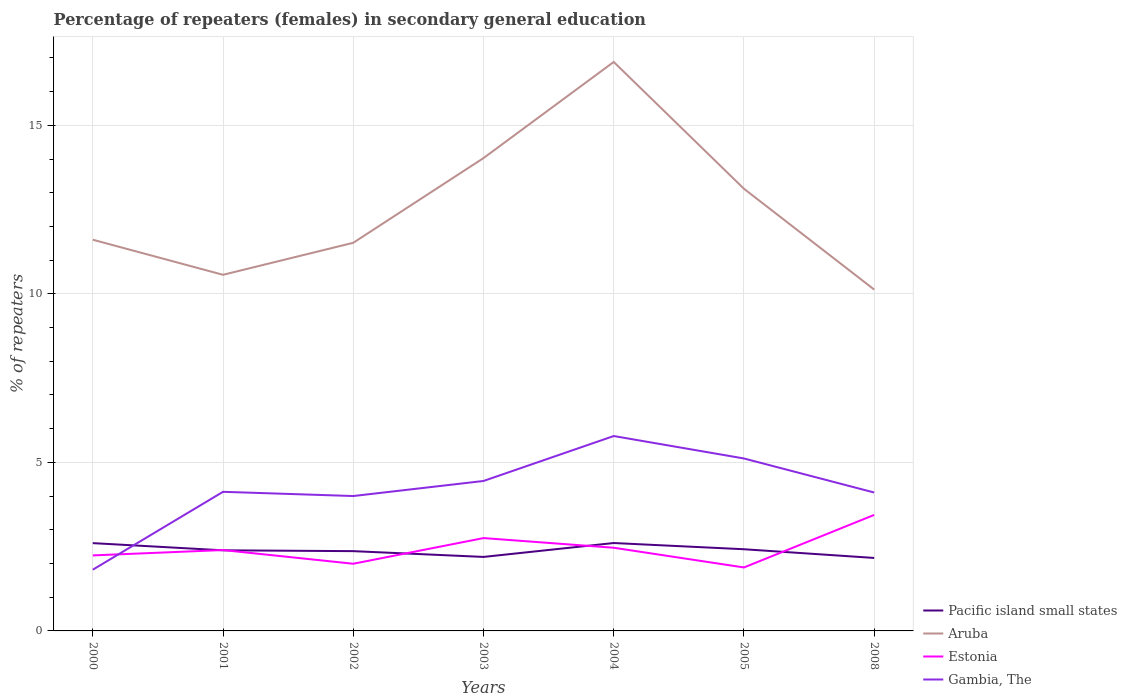How many different coloured lines are there?
Give a very brief answer. 4. Does the line corresponding to Aruba intersect with the line corresponding to Estonia?
Your response must be concise. No. Is the number of lines equal to the number of legend labels?
Give a very brief answer. Yes. Across all years, what is the maximum percentage of female repeaters in Gambia, The?
Keep it short and to the point. 1.82. What is the total percentage of female repeaters in Pacific island small states in the graph?
Keep it short and to the point. 0.18. What is the difference between the highest and the second highest percentage of female repeaters in Pacific island small states?
Offer a very short reply. 0.44. Is the percentage of female repeaters in Aruba strictly greater than the percentage of female repeaters in Estonia over the years?
Give a very brief answer. No. How many years are there in the graph?
Give a very brief answer. 7. Does the graph contain any zero values?
Your answer should be compact. No. Does the graph contain grids?
Your answer should be compact. Yes. Where does the legend appear in the graph?
Ensure brevity in your answer.  Bottom right. How many legend labels are there?
Your response must be concise. 4. How are the legend labels stacked?
Give a very brief answer. Vertical. What is the title of the graph?
Offer a terse response. Percentage of repeaters (females) in secondary general education. What is the label or title of the X-axis?
Provide a succinct answer. Years. What is the label or title of the Y-axis?
Offer a very short reply. % of repeaters. What is the % of repeaters of Pacific island small states in 2000?
Your answer should be compact. 2.6. What is the % of repeaters of Aruba in 2000?
Ensure brevity in your answer.  11.61. What is the % of repeaters in Estonia in 2000?
Provide a short and direct response. 2.24. What is the % of repeaters in Gambia, The in 2000?
Your answer should be compact. 1.82. What is the % of repeaters in Pacific island small states in 2001?
Ensure brevity in your answer.  2.39. What is the % of repeaters in Aruba in 2001?
Provide a short and direct response. 10.56. What is the % of repeaters of Estonia in 2001?
Keep it short and to the point. 2.4. What is the % of repeaters of Gambia, The in 2001?
Make the answer very short. 4.13. What is the % of repeaters in Pacific island small states in 2002?
Your answer should be compact. 2.37. What is the % of repeaters of Aruba in 2002?
Your answer should be very brief. 11.51. What is the % of repeaters in Estonia in 2002?
Offer a terse response. 1.99. What is the % of repeaters of Gambia, The in 2002?
Your response must be concise. 4. What is the % of repeaters of Pacific island small states in 2003?
Provide a succinct answer. 2.2. What is the % of repeaters in Aruba in 2003?
Your response must be concise. 14.03. What is the % of repeaters of Estonia in 2003?
Your answer should be very brief. 2.75. What is the % of repeaters of Gambia, The in 2003?
Provide a short and direct response. 4.45. What is the % of repeaters in Pacific island small states in 2004?
Your answer should be compact. 2.61. What is the % of repeaters in Aruba in 2004?
Keep it short and to the point. 16.88. What is the % of repeaters of Estonia in 2004?
Your answer should be very brief. 2.47. What is the % of repeaters in Gambia, The in 2004?
Give a very brief answer. 5.78. What is the % of repeaters of Pacific island small states in 2005?
Offer a very short reply. 2.42. What is the % of repeaters in Aruba in 2005?
Keep it short and to the point. 13.12. What is the % of repeaters in Estonia in 2005?
Your response must be concise. 1.88. What is the % of repeaters in Gambia, The in 2005?
Give a very brief answer. 5.12. What is the % of repeaters of Pacific island small states in 2008?
Your response must be concise. 2.16. What is the % of repeaters in Aruba in 2008?
Your answer should be compact. 10.13. What is the % of repeaters of Estonia in 2008?
Ensure brevity in your answer.  3.44. What is the % of repeaters in Gambia, The in 2008?
Offer a terse response. 4.11. Across all years, what is the maximum % of repeaters in Pacific island small states?
Ensure brevity in your answer.  2.61. Across all years, what is the maximum % of repeaters of Aruba?
Ensure brevity in your answer.  16.88. Across all years, what is the maximum % of repeaters in Estonia?
Keep it short and to the point. 3.44. Across all years, what is the maximum % of repeaters of Gambia, The?
Make the answer very short. 5.78. Across all years, what is the minimum % of repeaters of Pacific island small states?
Provide a succinct answer. 2.16. Across all years, what is the minimum % of repeaters in Aruba?
Give a very brief answer. 10.13. Across all years, what is the minimum % of repeaters of Estonia?
Provide a short and direct response. 1.88. Across all years, what is the minimum % of repeaters in Gambia, The?
Provide a succinct answer. 1.82. What is the total % of repeaters of Pacific island small states in the graph?
Your answer should be very brief. 16.75. What is the total % of repeaters of Aruba in the graph?
Your answer should be very brief. 87.83. What is the total % of repeaters of Estonia in the graph?
Ensure brevity in your answer.  17.18. What is the total % of repeaters of Gambia, The in the graph?
Keep it short and to the point. 29.4. What is the difference between the % of repeaters in Pacific island small states in 2000 and that in 2001?
Your answer should be compact. 0.21. What is the difference between the % of repeaters of Aruba in 2000 and that in 2001?
Make the answer very short. 1.04. What is the difference between the % of repeaters of Estonia in 2000 and that in 2001?
Make the answer very short. -0.16. What is the difference between the % of repeaters of Gambia, The in 2000 and that in 2001?
Make the answer very short. -2.31. What is the difference between the % of repeaters of Pacific island small states in 2000 and that in 2002?
Your answer should be very brief. 0.24. What is the difference between the % of repeaters in Aruba in 2000 and that in 2002?
Keep it short and to the point. 0.09. What is the difference between the % of repeaters in Estonia in 2000 and that in 2002?
Provide a succinct answer. 0.25. What is the difference between the % of repeaters of Gambia, The in 2000 and that in 2002?
Provide a succinct answer. -2.19. What is the difference between the % of repeaters of Pacific island small states in 2000 and that in 2003?
Provide a succinct answer. 0.41. What is the difference between the % of repeaters of Aruba in 2000 and that in 2003?
Offer a terse response. -2.42. What is the difference between the % of repeaters in Estonia in 2000 and that in 2003?
Your answer should be compact. -0.51. What is the difference between the % of repeaters of Gambia, The in 2000 and that in 2003?
Offer a terse response. -2.63. What is the difference between the % of repeaters in Pacific island small states in 2000 and that in 2004?
Provide a short and direct response. -0. What is the difference between the % of repeaters of Aruba in 2000 and that in 2004?
Your answer should be very brief. -5.27. What is the difference between the % of repeaters in Estonia in 2000 and that in 2004?
Provide a short and direct response. -0.23. What is the difference between the % of repeaters of Gambia, The in 2000 and that in 2004?
Keep it short and to the point. -3.97. What is the difference between the % of repeaters of Pacific island small states in 2000 and that in 2005?
Give a very brief answer. 0.18. What is the difference between the % of repeaters of Aruba in 2000 and that in 2005?
Your response must be concise. -1.51. What is the difference between the % of repeaters of Estonia in 2000 and that in 2005?
Keep it short and to the point. 0.36. What is the difference between the % of repeaters of Gambia, The in 2000 and that in 2005?
Offer a very short reply. -3.3. What is the difference between the % of repeaters of Pacific island small states in 2000 and that in 2008?
Your answer should be compact. 0.44. What is the difference between the % of repeaters in Aruba in 2000 and that in 2008?
Keep it short and to the point. 1.48. What is the difference between the % of repeaters of Estonia in 2000 and that in 2008?
Offer a terse response. -1.2. What is the difference between the % of repeaters of Gambia, The in 2000 and that in 2008?
Your response must be concise. -2.29. What is the difference between the % of repeaters in Pacific island small states in 2001 and that in 2002?
Your answer should be very brief. 0.02. What is the difference between the % of repeaters of Aruba in 2001 and that in 2002?
Give a very brief answer. -0.95. What is the difference between the % of repeaters of Estonia in 2001 and that in 2002?
Offer a terse response. 0.41. What is the difference between the % of repeaters in Gambia, The in 2001 and that in 2002?
Provide a succinct answer. 0.13. What is the difference between the % of repeaters in Pacific island small states in 2001 and that in 2003?
Your response must be concise. 0.2. What is the difference between the % of repeaters in Aruba in 2001 and that in 2003?
Your answer should be compact. -3.46. What is the difference between the % of repeaters in Estonia in 2001 and that in 2003?
Your answer should be compact. -0.35. What is the difference between the % of repeaters in Gambia, The in 2001 and that in 2003?
Provide a succinct answer. -0.32. What is the difference between the % of repeaters of Pacific island small states in 2001 and that in 2004?
Provide a short and direct response. -0.22. What is the difference between the % of repeaters of Aruba in 2001 and that in 2004?
Provide a short and direct response. -6.31. What is the difference between the % of repeaters in Estonia in 2001 and that in 2004?
Give a very brief answer. -0.07. What is the difference between the % of repeaters in Gambia, The in 2001 and that in 2004?
Your answer should be compact. -1.65. What is the difference between the % of repeaters of Pacific island small states in 2001 and that in 2005?
Your answer should be compact. -0.03. What is the difference between the % of repeaters in Aruba in 2001 and that in 2005?
Provide a succinct answer. -2.55. What is the difference between the % of repeaters in Estonia in 2001 and that in 2005?
Provide a short and direct response. 0.52. What is the difference between the % of repeaters in Gambia, The in 2001 and that in 2005?
Your response must be concise. -0.99. What is the difference between the % of repeaters of Pacific island small states in 2001 and that in 2008?
Offer a very short reply. 0.23. What is the difference between the % of repeaters in Aruba in 2001 and that in 2008?
Your answer should be compact. 0.44. What is the difference between the % of repeaters of Estonia in 2001 and that in 2008?
Your answer should be compact. -1.04. What is the difference between the % of repeaters in Gambia, The in 2001 and that in 2008?
Give a very brief answer. 0.02. What is the difference between the % of repeaters of Pacific island small states in 2002 and that in 2003?
Offer a very short reply. 0.17. What is the difference between the % of repeaters of Aruba in 2002 and that in 2003?
Make the answer very short. -2.51. What is the difference between the % of repeaters of Estonia in 2002 and that in 2003?
Your answer should be compact. -0.76. What is the difference between the % of repeaters in Gambia, The in 2002 and that in 2003?
Give a very brief answer. -0.45. What is the difference between the % of repeaters of Pacific island small states in 2002 and that in 2004?
Provide a succinct answer. -0.24. What is the difference between the % of repeaters in Aruba in 2002 and that in 2004?
Your answer should be very brief. -5.36. What is the difference between the % of repeaters in Estonia in 2002 and that in 2004?
Make the answer very short. -0.47. What is the difference between the % of repeaters of Gambia, The in 2002 and that in 2004?
Provide a short and direct response. -1.78. What is the difference between the % of repeaters in Pacific island small states in 2002 and that in 2005?
Provide a succinct answer. -0.06. What is the difference between the % of repeaters in Aruba in 2002 and that in 2005?
Your answer should be very brief. -1.6. What is the difference between the % of repeaters in Estonia in 2002 and that in 2005?
Keep it short and to the point. 0.11. What is the difference between the % of repeaters of Gambia, The in 2002 and that in 2005?
Your response must be concise. -1.11. What is the difference between the % of repeaters of Pacific island small states in 2002 and that in 2008?
Your response must be concise. 0.2. What is the difference between the % of repeaters of Aruba in 2002 and that in 2008?
Give a very brief answer. 1.39. What is the difference between the % of repeaters in Estonia in 2002 and that in 2008?
Your answer should be compact. -1.45. What is the difference between the % of repeaters in Gambia, The in 2002 and that in 2008?
Give a very brief answer. -0.1. What is the difference between the % of repeaters of Pacific island small states in 2003 and that in 2004?
Offer a very short reply. -0.41. What is the difference between the % of repeaters in Aruba in 2003 and that in 2004?
Ensure brevity in your answer.  -2.85. What is the difference between the % of repeaters of Estonia in 2003 and that in 2004?
Provide a succinct answer. 0.29. What is the difference between the % of repeaters of Gambia, The in 2003 and that in 2004?
Make the answer very short. -1.33. What is the difference between the % of repeaters in Pacific island small states in 2003 and that in 2005?
Your answer should be compact. -0.23. What is the difference between the % of repeaters of Aruba in 2003 and that in 2005?
Provide a succinct answer. 0.91. What is the difference between the % of repeaters in Estonia in 2003 and that in 2005?
Offer a very short reply. 0.87. What is the difference between the % of repeaters in Gambia, The in 2003 and that in 2005?
Your response must be concise. -0.67. What is the difference between the % of repeaters of Pacific island small states in 2003 and that in 2008?
Offer a terse response. 0.03. What is the difference between the % of repeaters of Aruba in 2003 and that in 2008?
Provide a short and direct response. 3.9. What is the difference between the % of repeaters in Estonia in 2003 and that in 2008?
Provide a short and direct response. -0.69. What is the difference between the % of repeaters of Gambia, The in 2003 and that in 2008?
Your answer should be compact. 0.34. What is the difference between the % of repeaters of Pacific island small states in 2004 and that in 2005?
Make the answer very short. 0.18. What is the difference between the % of repeaters in Aruba in 2004 and that in 2005?
Your answer should be compact. 3.76. What is the difference between the % of repeaters in Estonia in 2004 and that in 2005?
Offer a very short reply. 0.58. What is the difference between the % of repeaters of Gambia, The in 2004 and that in 2005?
Keep it short and to the point. 0.67. What is the difference between the % of repeaters of Pacific island small states in 2004 and that in 2008?
Offer a terse response. 0.44. What is the difference between the % of repeaters in Aruba in 2004 and that in 2008?
Offer a terse response. 6.75. What is the difference between the % of repeaters in Estonia in 2004 and that in 2008?
Ensure brevity in your answer.  -0.97. What is the difference between the % of repeaters of Gambia, The in 2004 and that in 2008?
Give a very brief answer. 1.68. What is the difference between the % of repeaters of Pacific island small states in 2005 and that in 2008?
Your answer should be very brief. 0.26. What is the difference between the % of repeaters of Aruba in 2005 and that in 2008?
Give a very brief answer. 2.99. What is the difference between the % of repeaters of Estonia in 2005 and that in 2008?
Provide a short and direct response. -1.56. What is the difference between the % of repeaters in Gambia, The in 2005 and that in 2008?
Your response must be concise. 1.01. What is the difference between the % of repeaters of Pacific island small states in 2000 and the % of repeaters of Aruba in 2001?
Keep it short and to the point. -7.96. What is the difference between the % of repeaters of Pacific island small states in 2000 and the % of repeaters of Estonia in 2001?
Your answer should be very brief. 0.21. What is the difference between the % of repeaters of Pacific island small states in 2000 and the % of repeaters of Gambia, The in 2001?
Provide a short and direct response. -1.52. What is the difference between the % of repeaters in Aruba in 2000 and the % of repeaters in Estonia in 2001?
Offer a terse response. 9.21. What is the difference between the % of repeaters of Aruba in 2000 and the % of repeaters of Gambia, The in 2001?
Ensure brevity in your answer.  7.48. What is the difference between the % of repeaters of Estonia in 2000 and the % of repeaters of Gambia, The in 2001?
Give a very brief answer. -1.89. What is the difference between the % of repeaters of Pacific island small states in 2000 and the % of repeaters of Aruba in 2002?
Make the answer very short. -8.91. What is the difference between the % of repeaters of Pacific island small states in 2000 and the % of repeaters of Estonia in 2002?
Make the answer very short. 0.61. What is the difference between the % of repeaters in Pacific island small states in 2000 and the % of repeaters in Gambia, The in 2002?
Keep it short and to the point. -1.4. What is the difference between the % of repeaters in Aruba in 2000 and the % of repeaters in Estonia in 2002?
Offer a terse response. 9.61. What is the difference between the % of repeaters of Aruba in 2000 and the % of repeaters of Gambia, The in 2002?
Keep it short and to the point. 7.6. What is the difference between the % of repeaters of Estonia in 2000 and the % of repeaters of Gambia, The in 2002?
Ensure brevity in your answer.  -1.76. What is the difference between the % of repeaters in Pacific island small states in 2000 and the % of repeaters in Aruba in 2003?
Offer a very short reply. -11.42. What is the difference between the % of repeaters of Pacific island small states in 2000 and the % of repeaters of Estonia in 2003?
Provide a short and direct response. -0.15. What is the difference between the % of repeaters of Pacific island small states in 2000 and the % of repeaters of Gambia, The in 2003?
Make the answer very short. -1.84. What is the difference between the % of repeaters of Aruba in 2000 and the % of repeaters of Estonia in 2003?
Keep it short and to the point. 8.85. What is the difference between the % of repeaters in Aruba in 2000 and the % of repeaters in Gambia, The in 2003?
Your response must be concise. 7.16. What is the difference between the % of repeaters in Estonia in 2000 and the % of repeaters in Gambia, The in 2003?
Ensure brevity in your answer.  -2.21. What is the difference between the % of repeaters in Pacific island small states in 2000 and the % of repeaters in Aruba in 2004?
Your answer should be very brief. -14.27. What is the difference between the % of repeaters of Pacific island small states in 2000 and the % of repeaters of Estonia in 2004?
Your answer should be compact. 0.14. What is the difference between the % of repeaters in Pacific island small states in 2000 and the % of repeaters in Gambia, The in 2004?
Your answer should be very brief. -3.18. What is the difference between the % of repeaters in Aruba in 2000 and the % of repeaters in Estonia in 2004?
Keep it short and to the point. 9.14. What is the difference between the % of repeaters of Aruba in 2000 and the % of repeaters of Gambia, The in 2004?
Make the answer very short. 5.82. What is the difference between the % of repeaters in Estonia in 2000 and the % of repeaters in Gambia, The in 2004?
Give a very brief answer. -3.54. What is the difference between the % of repeaters in Pacific island small states in 2000 and the % of repeaters in Aruba in 2005?
Make the answer very short. -10.51. What is the difference between the % of repeaters of Pacific island small states in 2000 and the % of repeaters of Estonia in 2005?
Provide a short and direct response. 0.72. What is the difference between the % of repeaters in Pacific island small states in 2000 and the % of repeaters in Gambia, The in 2005?
Give a very brief answer. -2.51. What is the difference between the % of repeaters of Aruba in 2000 and the % of repeaters of Estonia in 2005?
Offer a very short reply. 9.72. What is the difference between the % of repeaters in Aruba in 2000 and the % of repeaters in Gambia, The in 2005?
Your response must be concise. 6.49. What is the difference between the % of repeaters in Estonia in 2000 and the % of repeaters in Gambia, The in 2005?
Provide a short and direct response. -2.88. What is the difference between the % of repeaters of Pacific island small states in 2000 and the % of repeaters of Aruba in 2008?
Make the answer very short. -7.52. What is the difference between the % of repeaters of Pacific island small states in 2000 and the % of repeaters of Estonia in 2008?
Ensure brevity in your answer.  -0.84. What is the difference between the % of repeaters in Pacific island small states in 2000 and the % of repeaters in Gambia, The in 2008?
Provide a short and direct response. -1.5. What is the difference between the % of repeaters in Aruba in 2000 and the % of repeaters in Estonia in 2008?
Give a very brief answer. 8.16. What is the difference between the % of repeaters in Aruba in 2000 and the % of repeaters in Gambia, The in 2008?
Your response must be concise. 7.5. What is the difference between the % of repeaters of Estonia in 2000 and the % of repeaters of Gambia, The in 2008?
Ensure brevity in your answer.  -1.87. What is the difference between the % of repeaters of Pacific island small states in 2001 and the % of repeaters of Aruba in 2002?
Offer a terse response. -9.12. What is the difference between the % of repeaters of Pacific island small states in 2001 and the % of repeaters of Estonia in 2002?
Provide a succinct answer. 0.4. What is the difference between the % of repeaters of Pacific island small states in 2001 and the % of repeaters of Gambia, The in 2002?
Ensure brevity in your answer.  -1.61. What is the difference between the % of repeaters in Aruba in 2001 and the % of repeaters in Estonia in 2002?
Keep it short and to the point. 8.57. What is the difference between the % of repeaters of Aruba in 2001 and the % of repeaters of Gambia, The in 2002?
Provide a succinct answer. 6.56. What is the difference between the % of repeaters of Estonia in 2001 and the % of repeaters of Gambia, The in 2002?
Provide a short and direct response. -1.6. What is the difference between the % of repeaters in Pacific island small states in 2001 and the % of repeaters in Aruba in 2003?
Keep it short and to the point. -11.64. What is the difference between the % of repeaters of Pacific island small states in 2001 and the % of repeaters of Estonia in 2003?
Keep it short and to the point. -0.36. What is the difference between the % of repeaters in Pacific island small states in 2001 and the % of repeaters in Gambia, The in 2003?
Provide a short and direct response. -2.06. What is the difference between the % of repeaters of Aruba in 2001 and the % of repeaters of Estonia in 2003?
Offer a very short reply. 7.81. What is the difference between the % of repeaters in Aruba in 2001 and the % of repeaters in Gambia, The in 2003?
Make the answer very short. 6.12. What is the difference between the % of repeaters in Estonia in 2001 and the % of repeaters in Gambia, The in 2003?
Provide a succinct answer. -2.05. What is the difference between the % of repeaters in Pacific island small states in 2001 and the % of repeaters in Aruba in 2004?
Provide a short and direct response. -14.49. What is the difference between the % of repeaters of Pacific island small states in 2001 and the % of repeaters of Estonia in 2004?
Your response must be concise. -0.08. What is the difference between the % of repeaters of Pacific island small states in 2001 and the % of repeaters of Gambia, The in 2004?
Your response must be concise. -3.39. What is the difference between the % of repeaters of Aruba in 2001 and the % of repeaters of Estonia in 2004?
Give a very brief answer. 8.1. What is the difference between the % of repeaters in Aruba in 2001 and the % of repeaters in Gambia, The in 2004?
Offer a terse response. 4.78. What is the difference between the % of repeaters of Estonia in 2001 and the % of repeaters of Gambia, The in 2004?
Give a very brief answer. -3.38. What is the difference between the % of repeaters of Pacific island small states in 2001 and the % of repeaters of Aruba in 2005?
Make the answer very short. -10.73. What is the difference between the % of repeaters in Pacific island small states in 2001 and the % of repeaters in Estonia in 2005?
Your answer should be compact. 0.51. What is the difference between the % of repeaters in Pacific island small states in 2001 and the % of repeaters in Gambia, The in 2005?
Offer a very short reply. -2.72. What is the difference between the % of repeaters in Aruba in 2001 and the % of repeaters in Estonia in 2005?
Provide a succinct answer. 8.68. What is the difference between the % of repeaters in Aruba in 2001 and the % of repeaters in Gambia, The in 2005?
Provide a short and direct response. 5.45. What is the difference between the % of repeaters of Estonia in 2001 and the % of repeaters of Gambia, The in 2005?
Give a very brief answer. -2.72. What is the difference between the % of repeaters of Pacific island small states in 2001 and the % of repeaters of Aruba in 2008?
Your answer should be compact. -7.74. What is the difference between the % of repeaters of Pacific island small states in 2001 and the % of repeaters of Estonia in 2008?
Your response must be concise. -1.05. What is the difference between the % of repeaters in Pacific island small states in 2001 and the % of repeaters in Gambia, The in 2008?
Provide a succinct answer. -1.71. What is the difference between the % of repeaters of Aruba in 2001 and the % of repeaters of Estonia in 2008?
Provide a short and direct response. 7.12. What is the difference between the % of repeaters of Aruba in 2001 and the % of repeaters of Gambia, The in 2008?
Your answer should be compact. 6.46. What is the difference between the % of repeaters in Estonia in 2001 and the % of repeaters in Gambia, The in 2008?
Offer a terse response. -1.71. What is the difference between the % of repeaters of Pacific island small states in 2002 and the % of repeaters of Aruba in 2003?
Your answer should be very brief. -11.66. What is the difference between the % of repeaters in Pacific island small states in 2002 and the % of repeaters in Estonia in 2003?
Give a very brief answer. -0.39. What is the difference between the % of repeaters in Pacific island small states in 2002 and the % of repeaters in Gambia, The in 2003?
Give a very brief answer. -2.08. What is the difference between the % of repeaters of Aruba in 2002 and the % of repeaters of Estonia in 2003?
Give a very brief answer. 8.76. What is the difference between the % of repeaters of Aruba in 2002 and the % of repeaters of Gambia, The in 2003?
Your response must be concise. 7.07. What is the difference between the % of repeaters in Estonia in 2002 and the % of repeaters in Gambia, The in 2003?
Ensure brevity in your answer.  -2.46. What is the difference between the % of repeaters in Pacific island small states in 2002 and the % of repeaters in Aruba in 2004?
Your answer should be very brief. -14.51. What is the difference between the % of repeaters of Pacific island small states in 2002 and the % of repeaters of Estonia in 2004?
Ensure brevity in your answer.  -0.1. What is the difference between the % of repeaters in Pacific island small states in 2002 and the % of repeaters in Gambia, The in 2004?
Offer a very short reply. -3.41. What is the difference between the % of repeaters in Aruba in 2002 and the % of repeaters in Estonia in 2004?
Keep it short and to the point. 9.05. What is the difference between the % of repeaters in Aruba in 2002 and the % of repeaters in Gambia, The in 2004?
Your response must be concise. 5.73. What is the difference between the % of repeaters of Estonia in 2002 and the % of repeaters of Gambia, The in 2004?
Offer a very short reply. -3.79. What is the difference between the % of repeaters of Pacific island small states in 2002 and the % of repeaters of Aruba in 2005?
Provide a succinct answer. -10.75. What is the difference between the % of repeaters of Pacific island small states in 2002 and the % of repeaters of Estonia in 2005?
Provide a succinct answer. 0.48. What is the difference between the % of repeaters in Pacific island small states in 2002 and the % of repeaters in Gambia, The in 2005?
Offer a very short reply. -2.75. What is the difference between the % of repeaters of Aruba in 2002 and the % of repeaters of Estonia in 2005?
Provide a succinct answer. 9.63. What is the difference between the % of repeaters in Aruba in 2002 and the % of repeaters in Gambia, The in 2005?
Your answer should be very brief. 6.4. What is the difference between the % of repeaters in Estonia in 2002 and the % of repeaters in Gambia, The in 2005?
Make the answer very short. -3.12. What is the difference between the % of repeaters of Pacific island small states in 2002 and the % of repeaters of Aruba in 2008?
Offer a very short reply. -7.76. What is the difference between the % of repeaters in Pacific island small states in 2002 and the % of repeaters in Estonia in 2008?
Your answer should be very brief. -1.07. What is the difference between the % of repeaters in Pacific island small states in 2002 and the % of repeaters in Gambia, The in 2008?
Your answer should be very brief. -1.74. What is the difference between the % of repeaters of Aruba in 2002 and the % of repeaters of Estonia in 2008?
Offer a terse response. 8.07. What is the difference between the % of repeaters of Aruba in 2002 and the % of repeaters of Gambia, The in 2008?
Offer a very short reply. 7.41. What is the difference between the % of repeaters in Estonia in 2002 and the % of repeaters in Gambia, The in 2008?
Provide a succinct answer. -2.11. What is the difference between the % of repeaters in Pacific island small states in 2003 and the % of repeaters in Aruba in 2004?
Provide a succinct answer. -14.68. What is the difference between the % of repeaters in Pacific island small states in 2003 and the % of repeaters in Estonia in 2004?
Offer a terse response. -0.27. What is the difference between the % of repeaters of Pacific island small states in 2003 and the % of repeaters of Gambia, The in 2004?
Offer a terse response. -3.59. What is the difference between the % of repeaters in Aruba in 2003 and the % of repeaters in Estonia in 2004?
Provide a short and direct response. 11.56. What is the difference between the % of repeaters of Aruba in 2003 and the % of repeaters of Gambia, The in 2004?
Ensure brevity in your answer.  8.25. What is the difference between the % of repeaters in Estonia in 2003 and the % of repeaters in Gambia, The in 2004?
Provide a succinct answer. -3.03. What is the difference between the % of repeaters in Pacific island small states in 2003 and the % of repeaters in Aruba in 2005?
Keep it short and to the point. -10.92. What is the difference between the % of repeaters of Pacific island small states in 2003 and the % of repeaters of Estonia in 2005?
Keep it short and to the point. 0.31. What is the difference between the % of repeaters in Pacific island small states in 2003 and the % of repeaters in Gambia, The in 2005?
Offer a very short reply. -2.92. What is the difference between the % of repeaters in Aruba in 2003 and the % of repeaters in Estonia in 2005?
Make the answer very short. 12.14. What is the difference between the % of repeaters of Aruba in 2003 and the % of repeaters of Gambia, The in 2005?
Make the answer very short. 8.91. What is the difference between the % of repeaters of Estonia in 2003 and the % of repeaters of Gambia, The in 2005?
Make the answer very short. -2.36. What is the difference between the % of repeaters in Pacific island small states in 2003 and the % of repeaters in Aruba in 2008?
Keep it short and to the point. -7.93. What is the difference between the % of repeaters in Pacific island small states in 2003 and the % of repeaters in Estonia in 2008?
Offer a terse response. -1.25. What is the difference between the % of repeaters in Pacific island small states in 2003 and the % of repeaters in Gambia, The in 2008?
Give a very brief answer. -1.91. What is the difference between the % of repeaters of Aruba in 2003 and the % of repeaters of Estonia in 2008?
Offer a very short reply. 10.59. What is the difference between the % of repeaters in Aruba in 2003 and the % of repeaters in Gambia, The in 2008?
Keep it short and to the point. 9.92. What is the difference between the % of repeaters of Estonia in 2003 and the % of repeaters of Gambia, The in 2008?
Ensure brevity in your answer.  -1.35. What is the difference between the % of repeaters in Pacific island small states in 2004 and the % of repeaters in Aruba in 2005?
Make the answer very short. -10.51. What is the difference between the % of repeaters in Pacific island small states in 2004 and the % of repeaters in Estonia in 2005?
Your response must be concise. 0.72. What is the difference between the % of repeaters in Pacific island small states in 2004 and the % of repeaters in Gambia, The in 2005?
Make the answer very short. -2.51. What is the difference between the % of repeaters of Aruba in 2004 and the % of repeaters of Estonia in 2005?
Keep it short and to the point. 15. What is the difference between the % of repeaters in Aruba in 2004 and the % of repeaters in Gambia, The in 2005?
Keep it short and to the point. 11.76. What is the difference between the % of repeaters of Estonia in 2004 and the % of repeaters of Gambia, The in 2005?
Give a very brief answer. -2.65. What is the difference between the % of repeaters in Pacific island small states in 2004 and the % of repeaters in Aruba in 2008?
Your answer should be very brief. -7.52. What is the difference between the % of repeaters of Pacific island small states in 2004 and the % of repeaters of Estonia in 2008?
Offer a terse response. -0.83. What is the difference between the % of repeaters in Pacific island small states in 2004 and the % of repeaters in Gambia, The in 2008?
Give a very brief answer. -1.5. What is the difference between the % of repeaters of Aruba in 2004 and the % of repeaters of Estonia in 2008?
Offer a terse response. 13.44. What is the difference between the % of repeaters in Aruba in 2004 and the % of repeaters in Gambia, The in 2008?
Offer a terse response. 12.77. What is the difference between the % of repeaters in Estonia in 2004 and the % of repeaters in Gambia, The in 2008?
Keep it short and to the point. -1.64. What is the difference between the % of repeaters of Pacific island small states in 2005 and the % of repeaters of Aruba in 2008?
Offer a terse response. -7.7. What is the difference between the % of repeaters of Pacific island small states in 2005 and the % of repeaters of Estonia in 2008?
Provide a short and direct response. -1.02. What is the difference between the % of repeaters in Pacific island small states in 2005 and the % of repeaters in Gambia, The in 2008?
Offer a terse response. -1.68. What is the difference between the % of repeaters of Aruba in 2005 and the % of repeaters of Estonia in 2008?
Ensure brevity in your answer.  9.68. What is the difference between the % of repeaters of Aruba in 2005 and the % of repeaters of Gambia, The in 2008?
Your answer should be very brief. 9.01. What is the difference between the % of repeaters in Estonia in 2005 and the % of repeaters in Gambia, The in 2008?
Offer a very short reply. -2.22. What is the average % of repeaters of Pacific island small states per year?
Provide a short and direct response. 2.39. What is the average % of repeaters in Aruba per year?
Make the answer very short. 12.55. What is the average % of repeaters of Estonia per year?
Give a very brief answer. 2.45. What is the average % of repeaters of Gambia, The per year?
Your answer should be very brief. 4.2. In the year 2000, what is the difference between the % of repeaters in Pacific island small states and % of repeaters in Aruba?
Give a very brief answer. -9. In the year 2000, what is the difference between the % of repeaters in Pacific island small states and % of repeaters in Estonia?
Offer a terse response. 0.36. In the year 2000, what is the difference between the % of repeaters in Pacific island small states and % of repeaters in Gambia, The?
Offer a terse response. 0.79. In the year 2000, what is the difference between the % of repeaters in Aruba and % of repeaters in Estonia?
Ensure brevity in your answer.  9.37. In the year 2000, what is the difference between the % of repeaters of Aruba and % of repeaters of Gambia, The?
Offer a terse response. 9.79. In the year 2000, what is the difference between the % of repeaters in Estonia and % of repeaters in Gambia, The?
Provide a short and direct response. 0.42. In the year 2001, what is the difference between the % of repeaters in Pacific island small states and % of repeaters in Aruba?
Make the answer very short. -8.17. In the year 2001, what is the difference between the % of repeaters of Pacific island small states and % of repeaters of Estonia?
Your answer should be compact. -0.01. In the year 2001, what is the difference between the % of repeaters in Pacific island small states and % of repeaters in Gambia, The?
Give a very brief answer. -1.74. In the year 2001, what is the difference between the % of repeaters of Aruba and % of repeaters of Estonia?
Provide a succinct answer. 8.17. In the year 2001, what is the difference between the % of repeaters of Aruba and % of repeaters of Gambia, The?
Offer a very short reply. 6.44. In the year 2001, what is the difference between the % of repeaters in Estonia and % of repeaters in Gambia, The?
Your answer should be compact. -1.73. In the year 2002, what is the difference between the % of repeaters of Pacific island small states and % of repeaters of Aruba?
Keep it short and to the point. -9.15. In the year 2002, what is the difference between the % of repeaters in Pacific island small states and % of repeaters in Estonia?
Offer a terse response. 0.37. In the year 2002, what is the difference between the % of repeaters of Pacific island small states and % of repeaters of Gambia, The?
Make the answer very short. -1.63. In the year 2002, what is the difference between the % of repeaters in Aruba and % of repeaters in Estonia?
Make the answer very short. 9.52. In the year 2002, what is the difference between the % of repeaters of Aruba and % of repeaters of Gambia, The?
Make the answer very short. 7.51. In the year 2002, what is the difference between the % of repeaters in Estonia and % of repeaters in Gambia, The?
Provide a short and direct response. -2.01. In the year 2003, what is the difference between the % of repeaters of Pacific island small states and % of repeaters of Aruba?
Your answer should be compact. -11.83. In the year 2003, what is the difference between the % of repeaters in Pacific island small states and % of repeaters in Estonia?
Offer a terse response. -0.56. In the year 2003, what is the difference between the % of repeaters in Pacific island small states and % of repeaters in Gambia, The?
Your answer should be very brief. -2.25. In the year 2003, what is the difference between the % of repeaters of Aruba and % of repeaters of Estonia?
Your answer should be very brief. 11.27. In the year 2003, what is the difference between the % of repeaters of Aruba and % of repeaters of Gambia, The?
Keep it short and to the point. 9.58. In the year 2003, what is the difference between the % of repeaters in Estonia and % of repeaters in Gambia, The?
Ensure brevity in your answer.  -1.69. In the year 2004, what is the difference between the % of repeaters in Pacific island small states and % of repeaters in Aruba?
Keep it short and to the point. -14.27. In the year 2004, what is the difference between the % of repeaters in Pacific island small states and % of repeaters in Estonia?
Offer a terse response. 0.14. In the year 2004, what is the difference between the % of repeaters in Pacific island small states and % of repeaters in Gambia, The?
Give a very brief answer. -3.17. In the year 2004, what is the difference between the % of repeaters in Aruba and % of repeaters in Estonia?
Give a very brief answer. 14.41. In the year 2004, what is the difference between the % of repeaters in Aruba and % of repeaters in Gambia, The?
Keep it short and to the point. 11.1. In the year 2004, what is the difference between the % of repeaters in Estonia and % of repeaters in Gambia, The?
Offer a very short reply. -3.31. In the year 2005, what is the difference between the % of repeaters of Pacific island small states and % of repeaters of Aruba?
Your response must be concise. -10.69. In the year 2005, what is the difference between the % of repeaters in Pacific island small states and % of repeaters in Estonia?
Give a very brief answer. 0.54. In the year 2005, what is the difference between the % of repeaters of Pacific island small states and % of repeaters of Gambia, The?
Your answer should be very brief. -2.69. In the year 2005, what is the difference between the % of repeaters in Aruba and % of repeaters in Estonia?
Keep it short and to the point. 11.23. In the year 2005, what is the difference between the % of repeaters in Aruba and % of repeaters in Gambia, The?
Provide a short and direct response. 8. In the year 2005, what is the difference between the % of repeaters of Estonia and % of repeaters of Gambia, The?
Offer a very short reply. -3.23. In the year 2008, what is the difference between the % of repeaters of Pacific island small states and % of repeaters of Aruba?
Your answer should be very brief. -7.96. In the year 2008, what is the difference between the % of repeaters in Pacific island small states and % of repeaters in Estonia?
Provide a short and direct response. -1.28. In the year 2008, what is the difference between the % of repeaters in Pacific island small states and % of repeaters in Gambia, The?
Offer a terse response. -1.94. In the year 2008, what is the difference between the % of repeaters in Aruba and % of repeaters in Estonia?
Provide a succinct answer. 6.68. In the year 2008, what is the difference between the % of repeaters in Aruba and % of repeaters in Gambia, The?
Make the answer very short. 6.02. In the year 2008, what is the difference between the % of repeaters of Estonia and % of repeaters of Gambia, The?
Offer a very short reply. -0.66. What is the ratio of the % of repeaters in Pacific island small states in 2000 to that in 2001?
Provide a succinct answer. 1.09. What is the ratio of the % of repeaters of Aruba in 2000 to that in 2001?
Your answer should be very brief. 1.1. What is the ratio of the % of repeaters in Estonia in 2000 to that in 2001?
Ensure brevity in your answer.  0.93. What is the ratio of the % of repeaters of Gambia, The in 2000 to that in 2001?
Offer a terse response. 0.44. What is the ratio of the % of repeaters of Pacific island small states in 2000 to that in 2002?
Ensure brevity in your answer.  1.1. What is the ratio of the % of repeaters of Aruba in 2000 to that in 2002?
Keep it short and to the point. 1.01. What is the ratio of the % of repeaters in Estonia in 2000 to that in 2002?
Your answer should be compact. 1.12. What is the ratio of the % of repeaters of Gambia, The in 2000 to that in 2002?
Provide a short and direct response. 0.45. What is the ratio of the % of repeaters of Pacific island small states in 2000 to that in 2003?
Give a very brief answer. 1.19. What is the ratio of the % of repeaters of Aruba in 2000 to that in 2003?
Provide a short and direct response. 0.83. What is the ratio of the % of repeaters of Estonia in 2000 to that in 2003?
Your answer should be compact. 0.81. What is the ratio of the % of repeaters of Gambia, The in 2000 to that in 2003?
Offer a very short reply. 0.41. What is the ratio of the % of repeaters in Pacific island small states in 2000 to that in 2004?
Your response must be concise. 1. What is the ratio of the % of repeaters in Aruba in 2000 to that in 2004?
Keep it short and to the point. 0.69. What is the ratio of the % of repeaters of Estonia in 2000 to that in 2004?
Offer a terse response. 0.91. What is the ratio of the % of repeaters of Gambia, The in 2000 to that in 2004?
Give a very brief answer. 0.31. What is the ratio of the % of repeaters in Pacific island small states in 2000 to that in 2005?
Provide a succinct answer. 1.07. What is the ratio of the % of repeaters of Aruba in 2000 to that in 2005?
Ensure brevity in your answer.  0.88. What is the ratio of the % of repeaters of Estonia in 2000 to that in 2005?
Make the answer very short. 1.19. What is the ratio of the % of repeaters of Gambia, The in 2000 to that in 2005?
Give a very brief answer. 0.35. What is the ratio of the % of repeaters in Pacific island small states in 2000 to that in 2008?
Offer a terse response. 1.2. What is the ratio of the % of repeaters in Aruba in 2000 to that in 2008?
Offer a very short reply. 1.15. What is the ratio of the % of repeaters of Estonia in 2000 to that in 2008?
Offer a terse response. 0.65. What is the ratio of the % of repeaters of Gambia, The in 2000 to that in 2008?
Provide a succinct answer. 0.44. What is the ratio of the % of repeaters in Pacific island small states in 2001 to that in 2002?
Ensure brevity in your answer.  1.01. What is the ratio of the % of repeaters of Aruba in 2001 to that in 2002?
Keep it short and to the point. 0.92. What is the ratio of the % of repeaters of Estonia in 2001 to that in 2002?
Offer a very short reply. 1.2. What is the ratio of the % of repeaters in Gambia, The in 2001 to that in 2002?
Provide a short and direct response. 1.03. What is the ratio of the % of repeaters of Pacific island small states in 2001 to that in 2003?
Offer a terse response. 1.09. What is the ratio of the % of repeaters in Aruba in 2001 to that in 2003?
Provide a short and direct response. 0.75. What is the ratio of the % of repeaters of Estonia in 2001 to that in 2003?
Provide a short and direct response. 0.87. What is the ratio of the % of repeaters of Gambia, The in 2001 to that in 2003?
Make the answer very short. 0.93. What is the ratio of the % of repeaters in Pacific island small states in 2001 to that in 2004?
Provide a short and direct response. 0.92. What is the ratio of the % of repeaters of Aruba in 2001 to that in 2004?
Offer a terse response. 0.63. What is the ratio of the % of repeaters in Estonia in 2001 to that in 2004?
Make the answer very short. 0.97. What is the ratio of the % of repeaters in Gambia, The in 2001 to that in 2004?
Give a very brief answer. 0.71. What is the ratio of the % of repeaters of Aruba in 2001 to that in 2005?
Offer a terse response. 0.81. What is the ratio of the % of repeaters of Estonia in 2001 to that in 2005?
Your answer should be compact. 1.27. What is the ratio of the % of repeaters in Gambia, The in 2001 to that in 2005?
Offer a terse response. 0.81. What is the ratio of the % of repeaters of Pacific island small states in 2001 to that in 2008?
Make the answer very short. 1.1. What is the ratio of the % of repeaters in Aruba in 2001 to that in 2008?
Keep it short and to the point. 1.04. What is the ratio of the % of repeaters in Estonia in 2001 to that in 2008?
Your answer should be very brief. 0.7. What is the ratio of the % of repeaters in Pacific island small states in 2002 to that in 2003?
Provide a short and direct response. 1.08. What is the ratio of the % of repeaters in Aruba in 2002 to that in 2003?
Provide a short and direct response. 0.82. What is the ratio of the % of repeaters in Estonia in 2002 to that in 2003?
Offer a terse response. 0.72. What is the ratio of the % of repeaters in Gambia, The in 2002 to that in 2003?
Make the answer very short. 0.9. What is the ratio of the % of repeaters of Pacific island small states in 2002 to that in 2004?
Your answer should be compact. 0.91. What is the ratio of the % of repeaters in Aruba in 2002 to that in 2004?
Keep it short and to the point. 0.68. What is the ratio of the % of repeaters of Estonia in 2002 to that in 2004?
Your answer should be compact. 0.81. What is the ratio of the % of repeaters of Gambia, The in 2002 to that in 2004?
Make the answer very short. 0.69. What is the ratio of the % of repeaters of Pacific island small states in 2002 to that in 2005?
Give a very brief answer. 0.98. What is the ratio of the % of repeaters of Aruba in 2002 to that in 2005?
Provide a succinct answer. 0.88. What is the ratio of the % of repeaters in Estonia in 2002 to that in 2005?
Ensure brevity in your answer.  1.06. What is the ratio of the % of repeaters of Gambia, The in 2002 to that in 2005?
Keep it short and to the point. 0.78. What is the ratio of the % of repeaters in Pacific island small states in 2002 to that in 2008?
Offer a very short reply. 1.09. What is the ratio of the % of repeaters of Aruba in 2002 to that in 2008?
Keep it short and to the point. 1.14. What is the ratio of the % of repeaters of Estonia in 2002 to that in 2008?
Offer a very short reply. 0.58. What is the ratio of the % of repeaters in Gambia, The in 2002 to that in 2008?
Keep it short and to the point. 0.97. What is the ratio of the % of repeaters of Pacific island small states in 2003 to that in 2004?
Make the answer very short. 0.84. What is the ratio of the % of repeaters of Aruba in 2003 to that in 2004?
Ensure brevity in your answer.  0.83. What is the ratio of the % of repeaters of Estonia in 2003 to that in 2004?
Your answer should be compact. 1.12. What is the ratio of the % of repeaters in Gambia, The in 2003 to that in 2004?
Offer a very short reply. 0.77. What is the ratio of the % of repeaters in Pacific island small states in 2003 to that in 2005?
Give a very brief answer. 0.91. What is the ratio of the % of repeaters of Aruba in 2003 to that in 2005?
Offer a very short reply. 1.07. What is the ratio of the % of repeaters of Estonia in 2003 to that in 2005?
Keep it short and to the point. 1.46. What is the ratio of the % of repeaters in Gambia, The in 2003 to that in 2005?
Ensure brevity in your answer.  0.87. What is the ratio of the % of repeaters of Pacific island small states in 2003 to that in 2008?
Keep it short and to the point. 1.01. What is the ratio of the % of repeaters of Aruba in 2003 to that in 2008?
Give a very brief answer. 1.39. What is the ratio of the % of repeaters of Estonia in 2003 to that in 2008?
Your response must be concise. 0.8. What is the ratio of the % of repeaters in Gambia, The in 2003 to that in 2008?
Keep it short and to the point. 1.08. What is the ratio of the % of repeaters in Pacific island small states in 2004 to that in 2005?
Offer a very short reply. 1.08. What is the ratio of the % of repeaters in Aruba in 2004 to that in 2005?
Your answer should be very brief. 1.29. What is the ratio of the % of repeaters in Estonia in 2004 to that in 2005?
Keep it short and to the point. 1.31. What is the ratio of the % of repeaters in Gambia, The in 2004 to that in 2005?
Offer a terse response. 1.13. What is the ratio of the % of repeaters of Pacific island small states in 2004 to that in 2008?
Ensure brevity in your answer.  1.2. What is the ratio of the % of repeaters of Aruba in 2004 to that in 2008?
Offer a very short reply. 1.67. What is the ratio of the % of repeaters in Estonia in 2004 to that in 2008?
Offer a very short reply. 0.72. What is the ratio of the % of repeaters in Gambia, The in 2004 to that in 2008?
Your answer should be very brief. 1.41. What is the ratio of the % of repeaters of Pacific island small states in 2005 to that in 2008?
Your answer should be compact. 1.12. What is the ratio of the % of repeaters in Aruba in 2005 to that in 2008?
Offer a very short reply. 1.3. What is the ratio of the % of repeaters of Estonia in 2005 to that in 2008?
Your answer should be very brief. 0.55. What is the ratio of the % of repeaters of Gambia, The in 2005 to that in 2008?
Keep it short and to the point. 1.25. What is the difference between the highest and the second highest % of repeaters of Pacific island small states?
Provide a short and direct response. 0. What is the difference between the highest and the second highest % of repeaters in Aruba?
Your answer should be very brief. 2.85. What is the difference between the highest and the second highest % of repeaters in Estonia?
Make the answer very short. 0.69. What is the difference between the highest and the second highest % of repeaters in Gambia, The?
Your answer should be compact. 0.67. What is the difference between the highest and the lowest % of repeaters of Pacific island small states?
Offer a terse response. 0.44. What is the difference between the highest and the lowest % of repeaters in Aruba?
Provide a short and direct response. 6.75. What is the difference between the highest and the lowest % of repeaters of Estonia?
Your response must be concise. 1.56. What is the difference between the highest and the lowest % of repeaters of Gambia, The?
Your answer should be very brief. 3.97. 